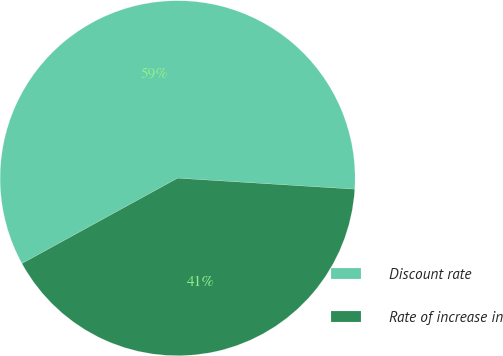Convert chart to OTSL. <chart><loc_0><loc_0><loc_500><loc_500><pie_chart><fcel>Discount rate<fcel>Rate of increase in<nl><fcel>58.97%<fcel>41.03%<nl></chart> 